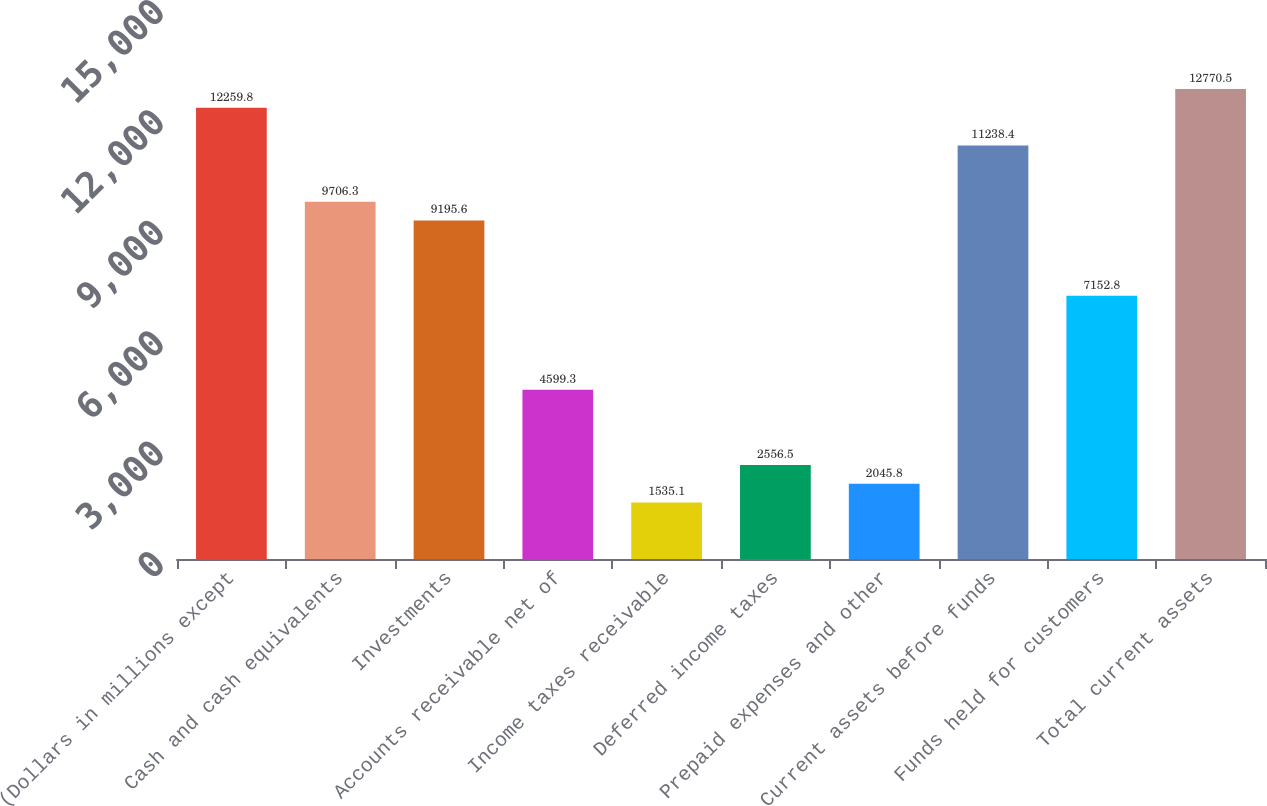Convert chart. <chart><loc_0><loc_0><loc_500><loc_500><bar_chart><fcel>(Dollars in millions except<fcel>Cash and cash equivalents<fcel>Investments<fcel>Accounts receivable net of<fcel>Income taxes receivable<fcel>Deferred income taxes<fcel>Prepaid expenses and other<fcel>Current assets before funds<fcel>Funds held for customers<fcel>Total current assets<nl><fcel>12259.8<fcel>9706.3<fcel>9195.6<fcel>4599.3<fcel>1535.1<fcel>2556.5<fcel>2045.8<fcel>11238.4<fcel>7152.8<fcel>12770.5<nl></chart> 